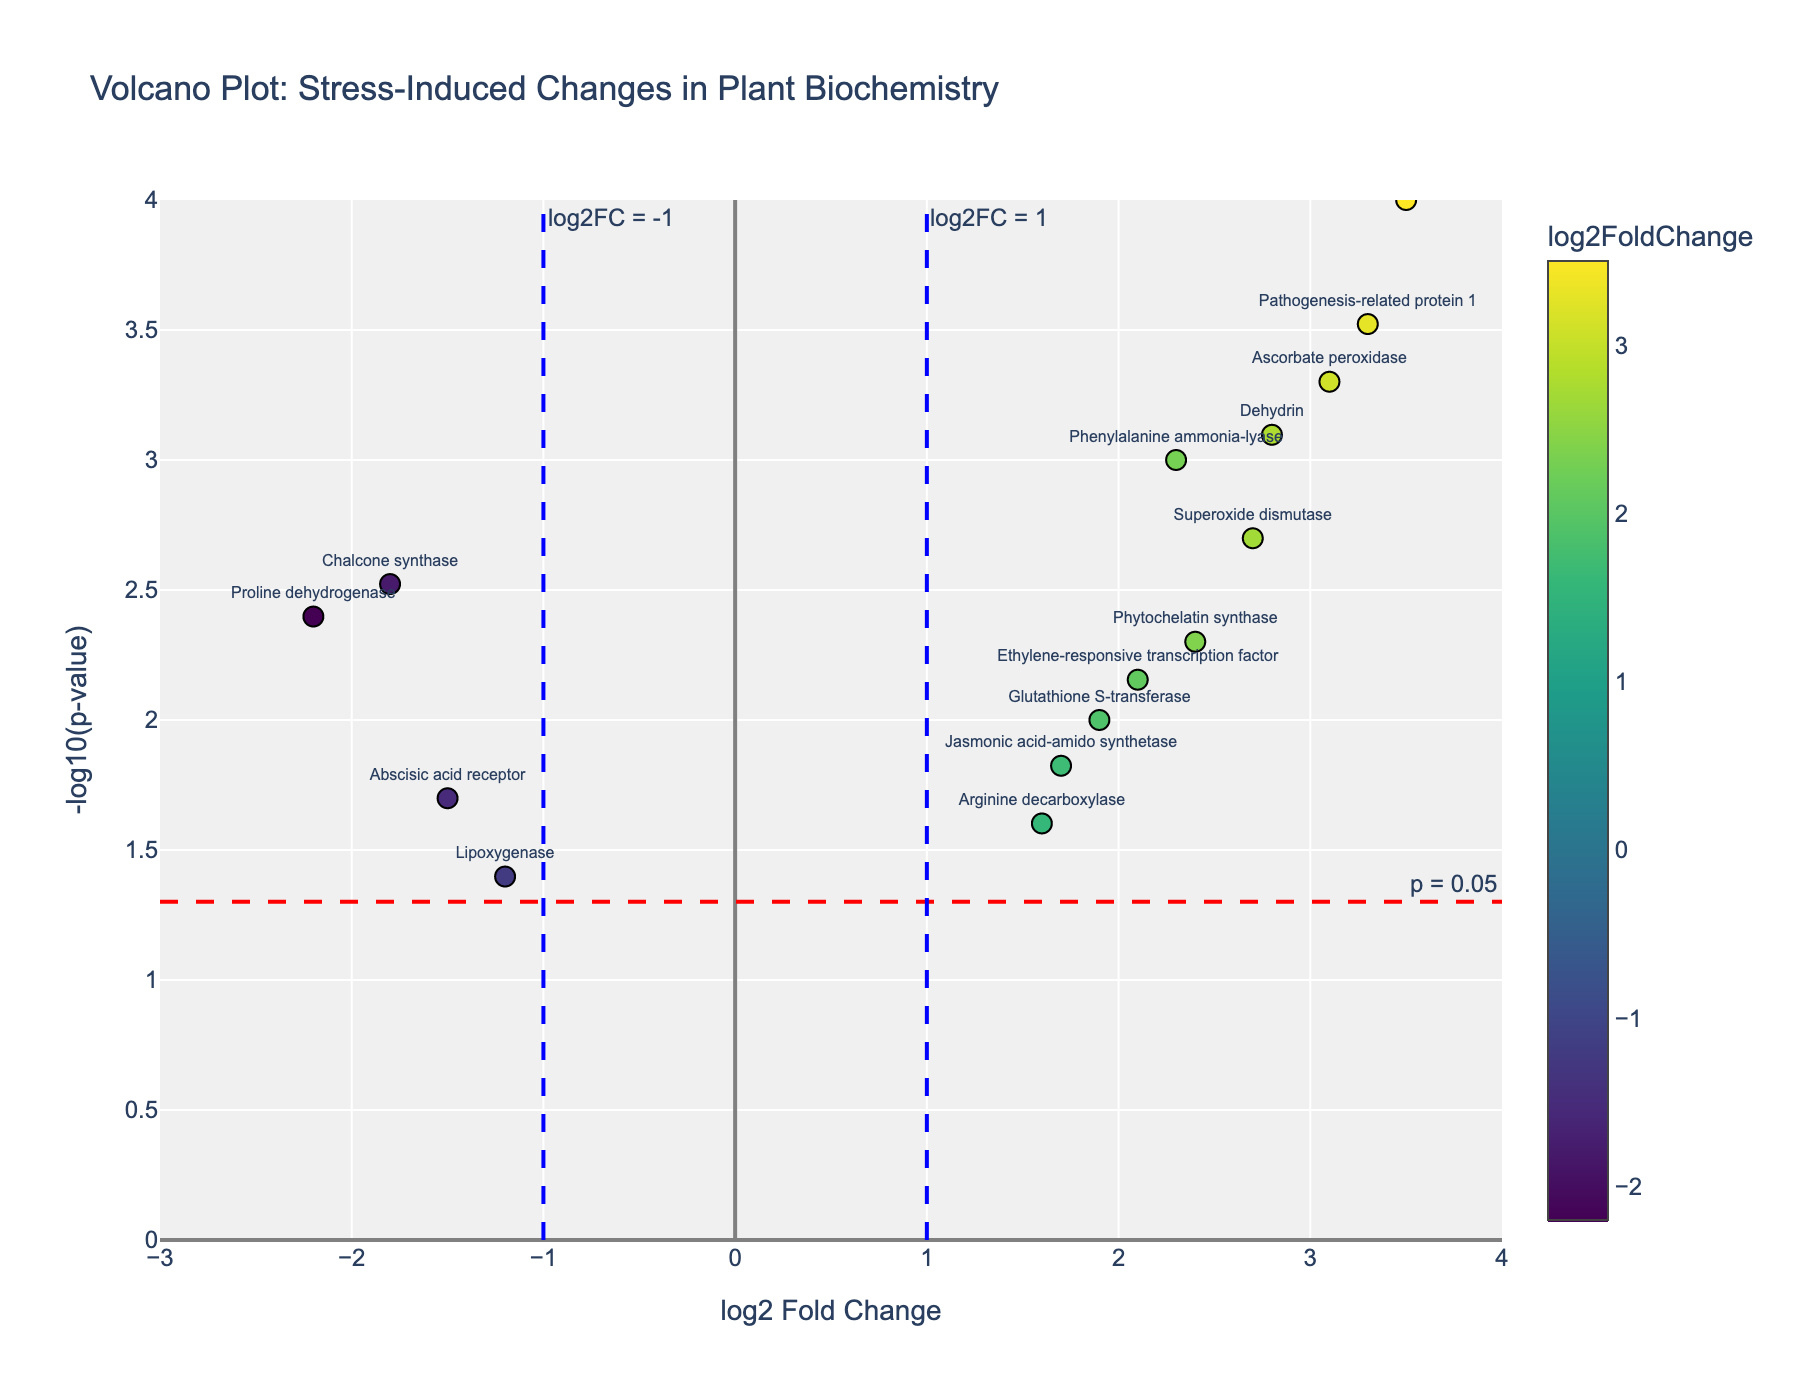What's the title of the plot? The title is located at the top of the plot and provides a brief description.
Answer: Volcano Plot: Stress-Induced Changes in Plant Biochemistry How many genes have a log2FoldChange greater than 1? We can count the number of data points to the right of the vertical blue line at x = 1.
Answer: Seven Which gene has the highest log2FoldChange? We locate the data point farthest to the right on the x-axis.
Answer: Heat shock protein 70 What's the -log10(p-value) threshold indicated by the red dashed line? The red dashed line has an annotation that marks the specific threshold value.
Answer: 1.301 What is the log2FoldChange and -log10(p-value) for Phenylalanine ammonia-lyase? Find the coordinates of the data point labeled as Phenylalanine ammonia-lyase.
Answer: 2.3 and 3.0 Which gene has the smallest p-value? The gene with the highest -log10(p-value) has the smallest p-value.
Answer: Heat shock protein 70 Which genes have a log2FoldChange between -1 and 1 but are still significant (p < 0.05)? We look for the genes between the two vertical blue lines and above the red horizontal line.
Answer: Arginine decarboxylase, Lipoxygenase, Abscisic acid receptor, and Jasmonic acid-amido synthetase How many genes are upregulated (positive log2FoldChange) and significant (p < 0.05)? Count the data points with positive log2FoldChange values and above the red horizontal line.
Answer: Nine Which gene is found at the coordinates (2.7, 2.698)? We look for the data point located at these specific coordinates.
Answer: Superoxide dismutase What's the range of -log10(p-value) shown on the y-axis? The y-axis starts from 0 and goes up to the maximum point. Based on the grid lines and marker, the range is from 0 to 4.
Answer: 0 to 4 